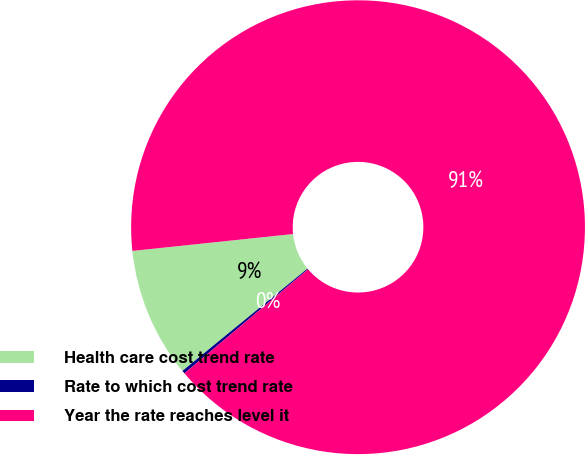Convert chart to OTSL. <chart><loc_0><loc_0><loc_500><loc_500><pie_chart><fcel>Health care cost trend rate<fcel>Rate to which cost trend rate<fcel>Year the rate reaches level it<nl><fcel>9.25%<fcel>0.22%<fcel>90.52%<nl></chart> 